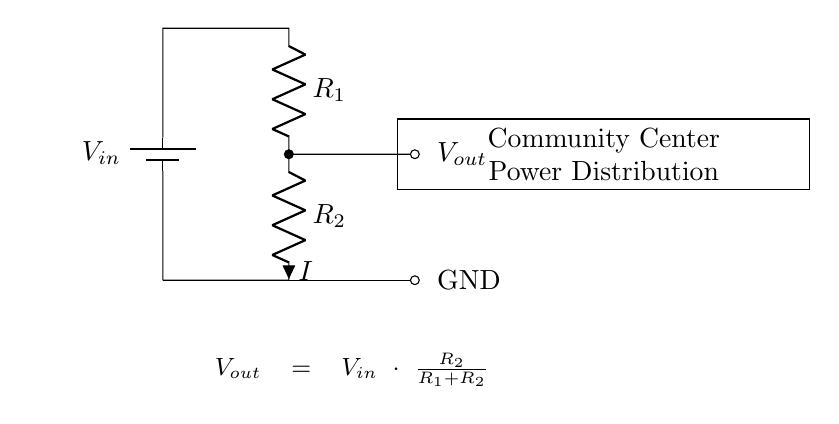What are the resistors in this circuit? The circuit includes two resistors: R1 and R2. They are connected in series and are crucial for dividing the input voltage.
Answer: R1, R2 What is the output voltage formula? The output voltage is given by the formula Vout = Vin * (R2 / (R1 + R2)), which describes how the voltage is divided between the resistors.
Answer: Vout = Vin * (R2 / (R1 + R2)) What is the role of R1 in the voltage divider? R1 determines the proportion of the input voltage that is dropped across it, affecting the voltage available across R2. It works with R2 to set Vout.
Answer: Voltage drop What happens to Vout if R2 increases? If R2 increases, the output voltage Vout will increase as well, due to the ratio in the output voltage formula becoming larger.
Answer: Vout increases What is the voltage at the ground terminal? The ground terminal is defined as the reference point for voltage in the circuit, which is 0 volts (V).
Answer: 0 volts What is meant by power distribution in this context? Power distribution refers to the method by which voltage is managed and delivered to various loads or devices within a community center circuit using the voltage divider.
Answer: Voltage management 